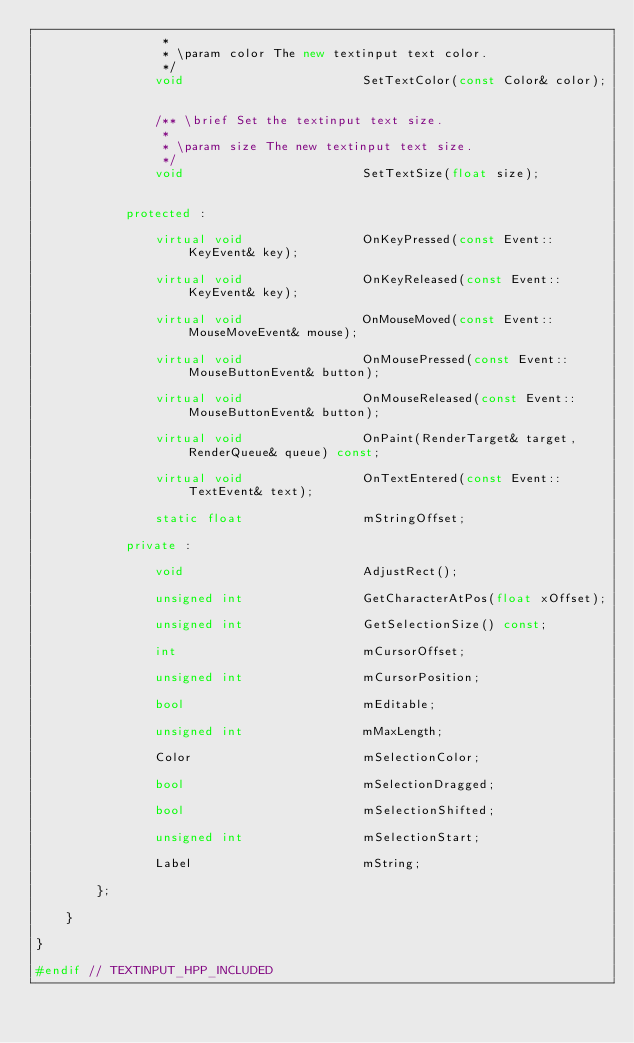Convert code to text. <code><loc_0><loc_0><loc_500><loc_500><_C++_>                 *
                 * \param color The new textinput text color.
                 */
                void                        SetTextColor(const Color& color);


                /** \brief Set the textinput text size.
                 *
                 * \param size The new textinput text size.
                 */
                void                        SetTextSize(float size);


            protected :

                virtual void                OnKeyPressed(const Event::KeyEvent& key);

                virtual void                OnKeyReleased(const Event::KeyEvent& key);

                virtual void                OnMouseMoved(const Event::MouseMoveEvent& mouse);

                virtual void                OnMousePressed(const Event::MouseButtonEvent& button);

                virtual void                OnMouseReleased(const Event::MouseButtonEvent& button);

                virtual void                OnPaint(RenderTarget& target, RenderQueue& queue) const;

                virtual void                OnTextEntered(const Event::TextEvent& text);

                static float                mStringOffset;

            private :

                void                        AdjustRect();

                unsigned int                GetCharacterAtPos(float xOffset);

                unsigned int                GetSelectionSize() const;

                int                         mCursorOffset;

                unsigned int                mCursorPosition;

                bool                        mEditable;

                unsigned int                mMaxLength;

                Color                       mSelectionColor;

                bool                        mSelectionDragged;

                bool                        mSelectionShifted;

                unsigned int                mSelectionStart;

                Label                       mString;

        };

    }

}

#endif // TEXTINPUT_HPP_INCLUDED
</code> 